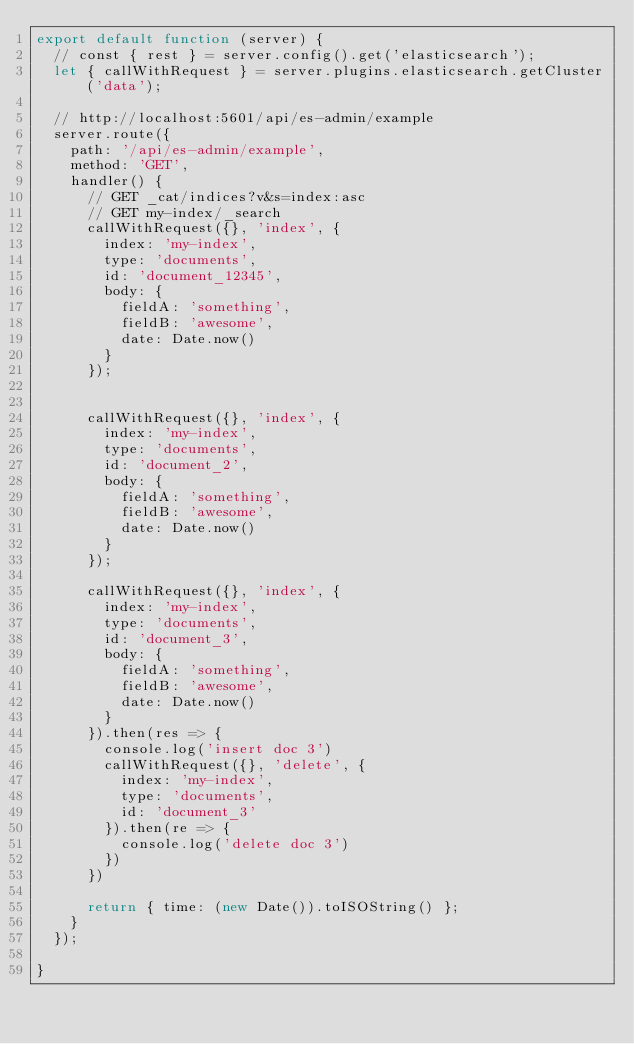Convert code to text. <code><loc_0><loc_0><loc_500><loc_500><_JavaScript_>export default function (server) {
  // const { rest } = server.config().get('elasticsearch');
  let { callWithRequest } = server.plugins.elasticsearch.getCluster('data');

  // http://localhost:5601/api/es-admin/example
  server.route({
    path: '/api/es-admin/example',
    method: 'GET',
    handler() {
      // GET _cat/indices?v&s=index:asc
      // GET my-index/_search
      callWithRequest({}, 'index', {
        index: 'my-index',
        type: 'documents',
        id: 'document_12345',
        body: {
          fieldA: 'something',
          fieldB: 'awesome',
          date: Date.now()
        }
      });


      callWithRequest({}, 'index', {
        index: 'my-index',
        type: 'documents',
        id: 'document_2',
        body: {
          fieldA: 'something',
          fieldB: 'awesome',
          date: Date.now()
        }
      });
      
      callWithRequest({}, 'index', {
        index: 'my-index',
        type: 'documents',
        id: 'document_3',
        body: {
          fieldA: 'something',
          fieldB: 'awesome',
          date: Date.now()
        }
      }).then(res => {
        console.log('insert doc 3')
        callWithRequest({}, 'delete', {
          index: 'my-index',
          type: 'documents',
          id: 'document_3'
        }).then(re => {
          console.log('delete doc 3')
        })
      })

      return { time: (new Date()).toISOString() };
    }
  });

}
</code> 